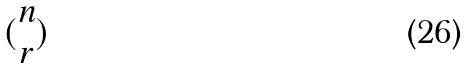<formula> <loc_0><loc_0><loc_500><loc_500>( \begin{matrix} n \\ r \end{matrix} )</formula> 